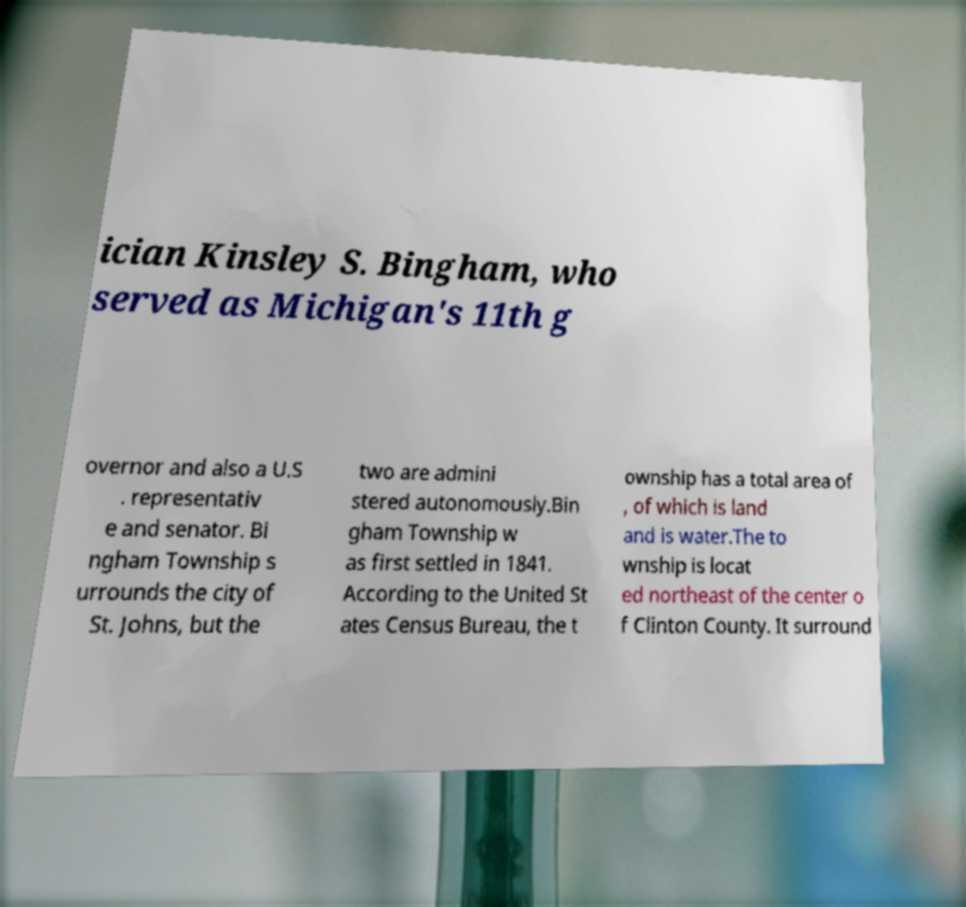Please read and relay the text visible in this image. What does it say? ician Kinsley S. Bingham, who served as Michigan's 11th g overnor and also a U.S . representativ e and senator. Bi ngham Township s urrounds the city of St. Johns, but the two are admini stered autonomously.Bin gham Township w as first settled in 1841. According to the United St ates Census Bureau, the t ownship has a total area of , of which is land and is water.The to wnship is locat ed northeast of the center o f Clinton County. It surround 